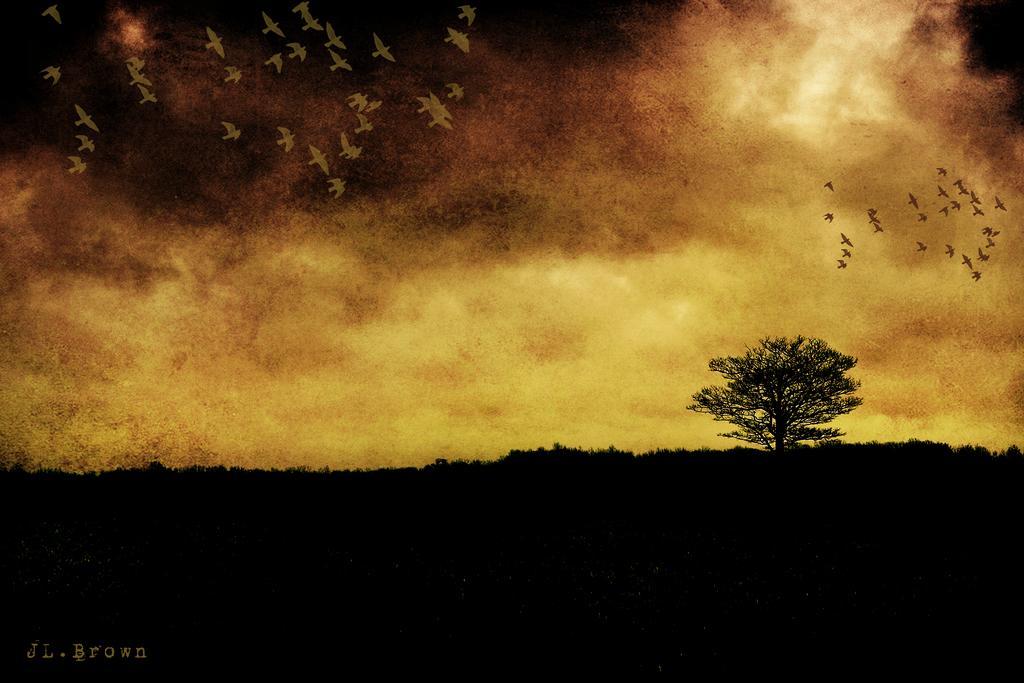How would you summarize this image in a sentence or two? In this image we can see a painting. There is a tree. Also there are many birds flying. In the background there is sky. In the left bottom corner something is written. 